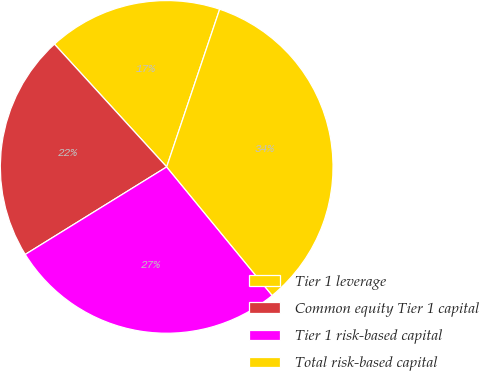<chart> <loc_0><loc_0><loc_500><loc_500><pie_chart><fcel>Tier 1 leverage<fcel>Common equity Tier 1 capital<fcel>Tier 1 risk-based capital<fcel>Total risk-based capital<nl><fcel>16.95%<fcel>22.03%<fcel>27.12%<fcel>33.9%<nl></chart> 